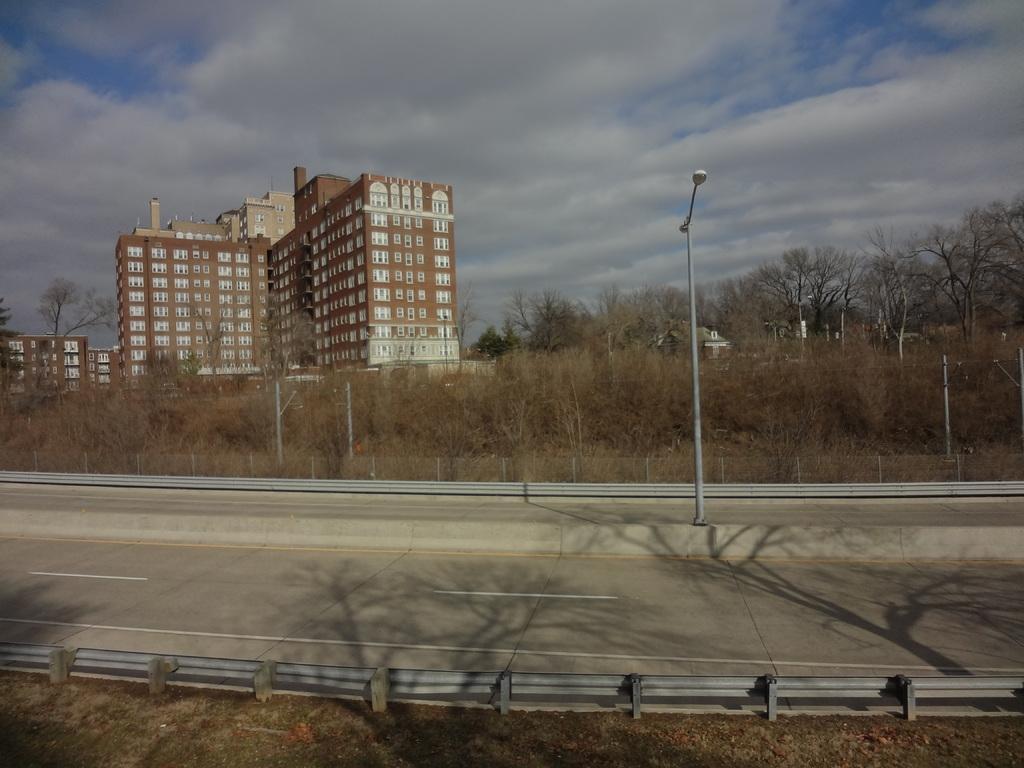Please provide a concise description of this image. This image is taken outdoors. At the top of the image there is the sky with clouds. At the bottom of the image there is a ground. In the background there are a few buildings and houses. There are many trees and plants. In the middle of the image there is a road and there is a fence. There is a pole with a street light. 